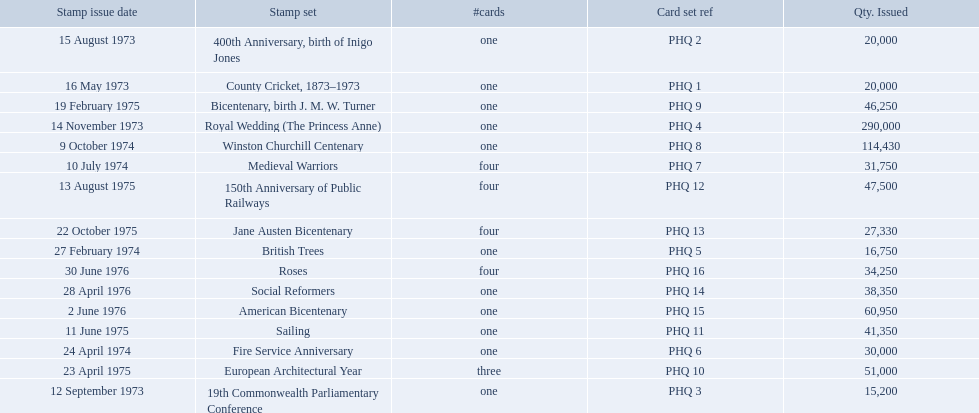What are all the stamp sets? County Cricket, 1873–1973, 400th Anniversary, birth of Inigo Jones, 19th Commonwealth Parliamentary Conference, Royal Wedding (The Princess Anne), British Trees, Fire Service Anniversary, Medieval Warriors, Winston Churchill Centenary, Bicentenary, birth J. M. W. Turner, European Architectural Year, Sailing, 150th Anniversary of Public Railways, Jane Austen Bicentenary, Social Reformers, American Bicentenary, Roses. For these sets, what were the quantities issued? 20,000, 20,000, 15,200, 290,000, 16,750, 30,000, 31,750, 114,430, 46,250, 51,000, 41,350, 47,500, 27,330, 38,350, 60,950, 34,250. Of these, which quantity is above 200,000? 290,000. What is the stamp set corresponding to this quantity? Royal Wedding (The Princess Anne). Which stamp sets were issued? County Cricket, 1873–1973, 400th Anniversary, birth of Inigo Jones, 19th Commonwealth Parliamentary Conference, Royal Wedding (The Princess Anne), British Trees, Fire Service Anniversary, Medieval Warriors, Winston Churchill Centenary, Bicentenary, birth J. M. W. Turner, European Architectural Year, Sailing, 150th Anniversary of Public Railways, Jane Austen Bicentenary, Social Reformers, American Bicentenary, Roses. Of those stamp sets, which had more that 200,000 issued? Royal Wedding (The Princess Anne). 